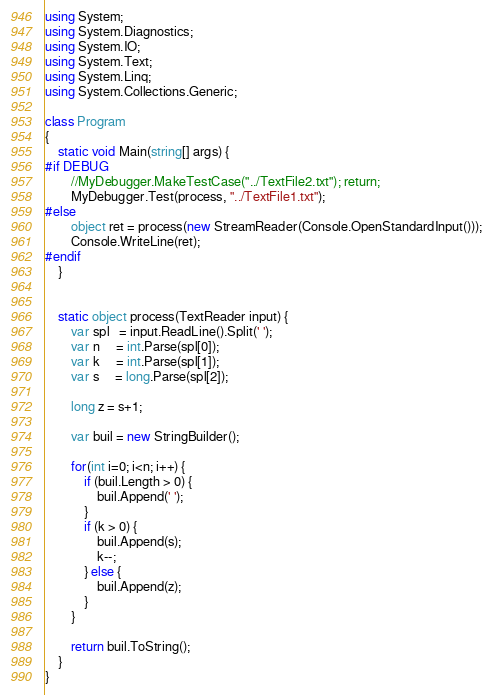<code> <loc_0><loc_0><loc_500><loc_500><_C#_>using System;
using System.Diagnostics;
using System.IO;
using System.Text;
using System.Linq;
using System.Collections.Generic;

class Program
{
    static void Main(string[] args) {
#if DEBUG
        //MyDebugger.MakeTestCase("../TextFile2.txt"); return;
        MyDebugger.Test(process, "../TextFile1.txt");
#else
        object ret = process(new StreamReader(Console.OpenStandardInput()));
        Console.WriteLine(ret);
#endif
    }


    static object process(TextReader input) {
        var spl   = input.ReadLine().Split(' ');
        var n     = int.Parse(spl[0]);
        var k     = int.Parse(spl[1]);
        var s     = long.Parse(spl[2]);
        
        long z = s+1;

        var buil = new StringBuilder();

        for(int i=0; i<n; i++) {
            if (buil.Length > 0) {            
                buil.Append(' ');
            }
            if (k > 0) {
                buil.Append(s);
                k--;
            } else {
                buil.Append(z);
            }
        }

        return buil.ToString();
    }
}
</code> 